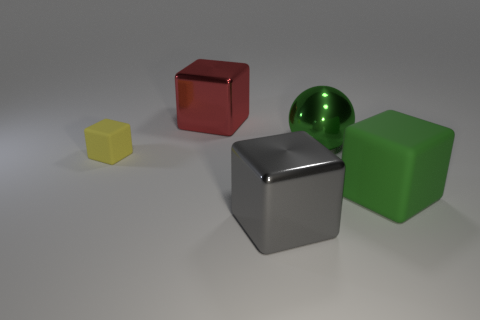Subtract all big cubes. How many cubes are left? 1 Subtract all brown cubes. Subtract all red spheres. How many cubes are left? 4 Add 4 big red blocks. How many objects exist? 9 Subtract 0 red spheres. How many objects are left? 5 Subtract all spheres. How many objects are left? 4 Subtract all tiny yellow matte things. Subtract all red blocks. How many objects are left? 3 Add 4 large red metal things. How many large red metal things are left? 5 Add 2 big brown rubber cubes. How many big brown rubber cubes exist? 2 